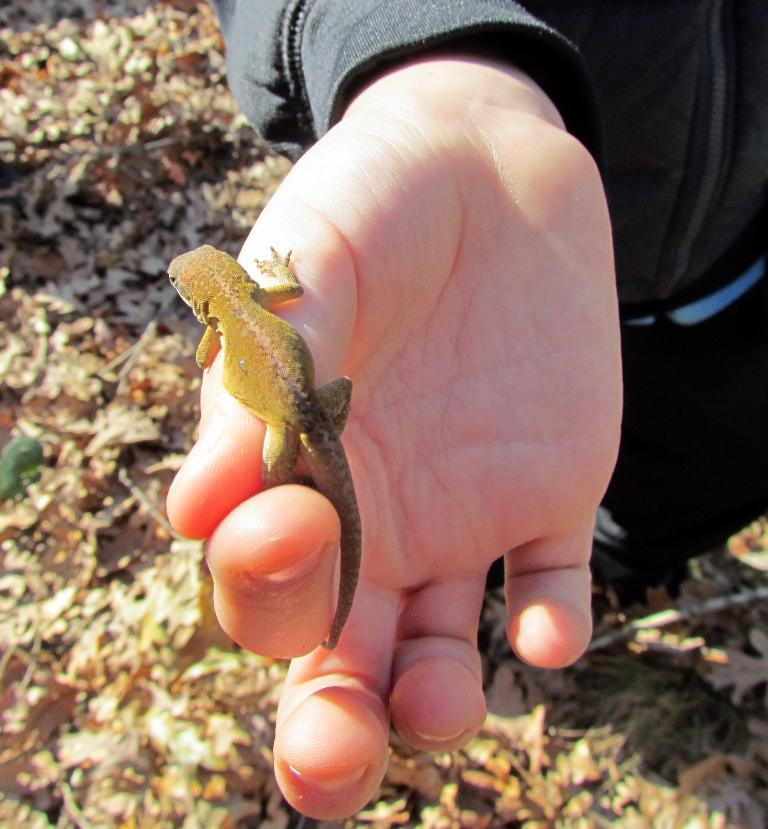What is visible on the person's hand in the image? There is a lizard on the hand in the image. Can you describe the lizard's appearance or characteristics? Unfortunately, the image does not provide enough detail to describe the lizard's appearance or characteristics. What flavor of toothpaste is the person using in the image? There is no toothpaste present in the image; it features a person's hand with a lizard on it. How does the person express their love for the lizard in the image? There is no indication of love or affection between the person and the lizard in the image; it simply shows a lizard on the person's hand. 